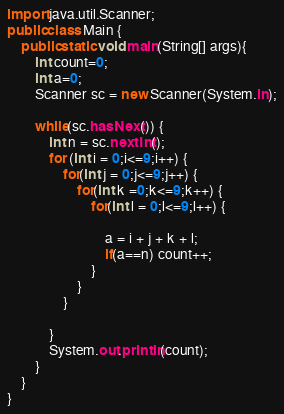Convert code to text. <code><loc_0><loc_0><loc_500><loc_500><_Java_>
import java.util.Scanner;
public class Main { 
	public static void main(String[] args){
		int count=0;
		int a=0;
		Scanner sc = new Scanner(System.in);
		
		while(sc.hasNext()) {
			int n = sc.nextInt();
			for (int i = 0;i<=9;i++) {
				for(int j = 0;j<=9;j++) {
					for(int k =0;k<=9;k++) {
						for(int l = 0;l<=9;l++) {
							
							a = i + j + k + l;
							if(a==n) count++;
						}
					}
				}

			}
			System.out.println(count);
		}
	}
}

</code> 